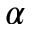Convert formula to latex. <formula><loc_0><loc_0><loc_500><loc_500>\alpha</formula> 